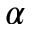Convert formula to latex. <formula><loc_0><loc_0><loc_500><loc_500>\alpha</formula> 